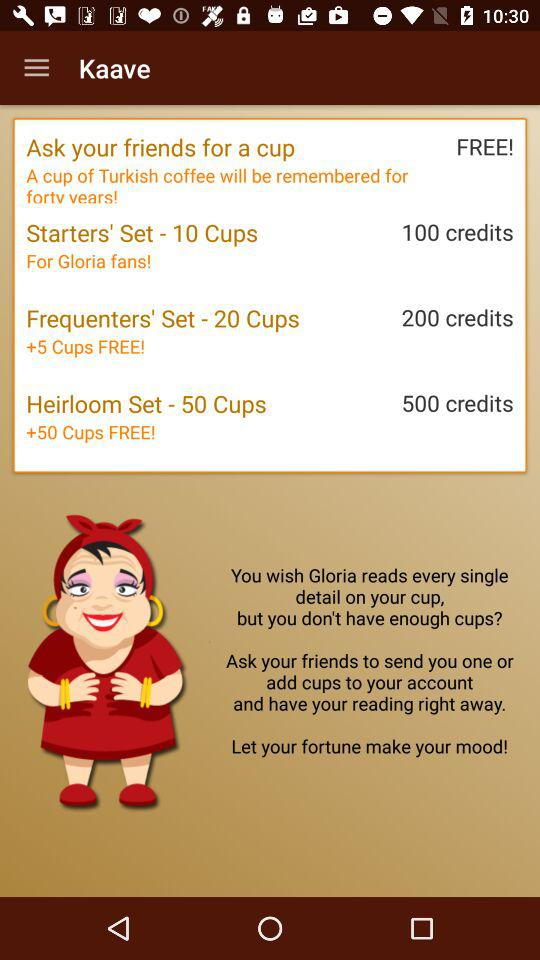How many cup sets are available?
Answer the question using a single word or phrase. 3 